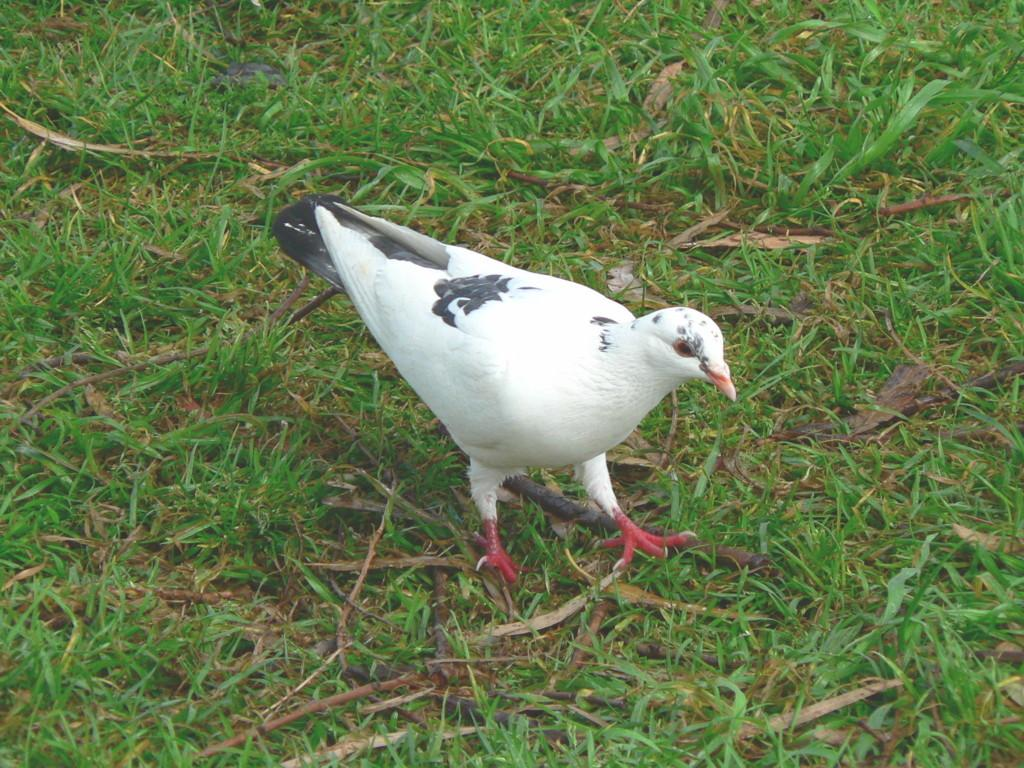What type of animal can be seen in the image? There is a bird in the image. Where is the bird located? The bird is on the grass. How many pizzas are being served by the slave in the image? There is no mention of pizzas or a slave in the image; it features a bird on the grass. Can you tell me the color of the kitty in the image? There is no kitty present in the image; it features a bird on the grass. 